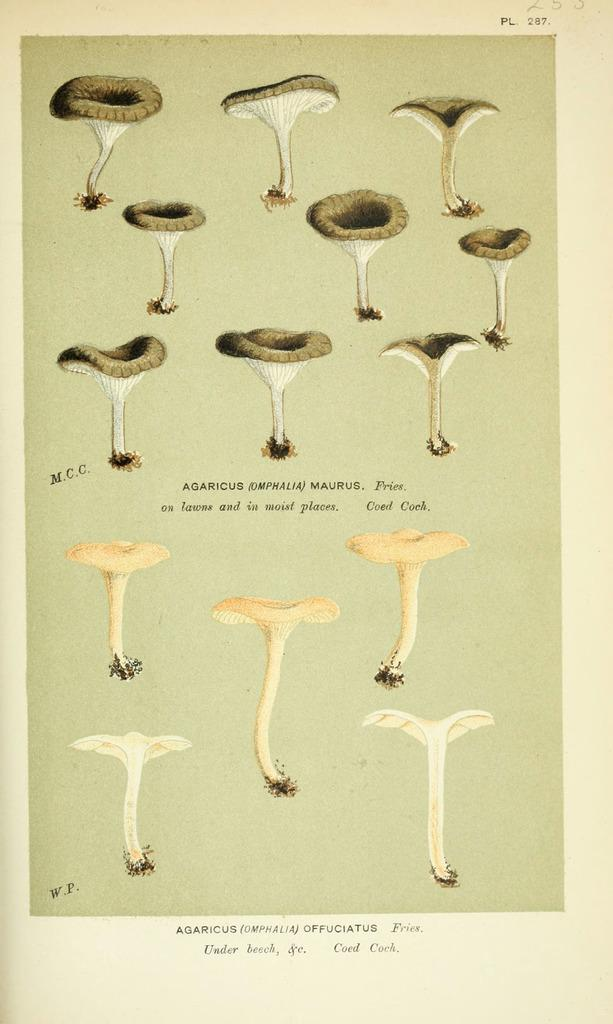What types of fungi are present in the image? There are different types of mushrooms in the image. Is there any text associated with the image? Yes, there is text written at the bottom of the image. How many pears are visible in the image? There are no pears present in the image; it features different types of mushrooms. What type of wax is used to create the texture of the mushrooms in the image? The image is not a physical object, so there is no wax used to create the texture of the mushrooms. 